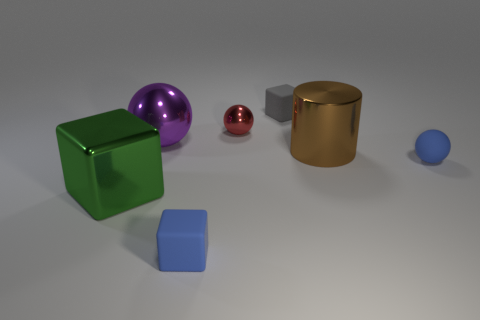Add 2 tiny gray shiny cylinders. How many objects exist? 9 Subtract all blocks. How many objects are left? 4 Add 4 tiny metallic objects. How many tiny metallic objects exist? 5 Subtract 0 cyan spheres. How many objects are left? 7 Subtract all large blue spheres. Subtract all blue spheres. How many objects are left? 6 Add 1 big metal blocks. How many big metal blocks are left? 2 